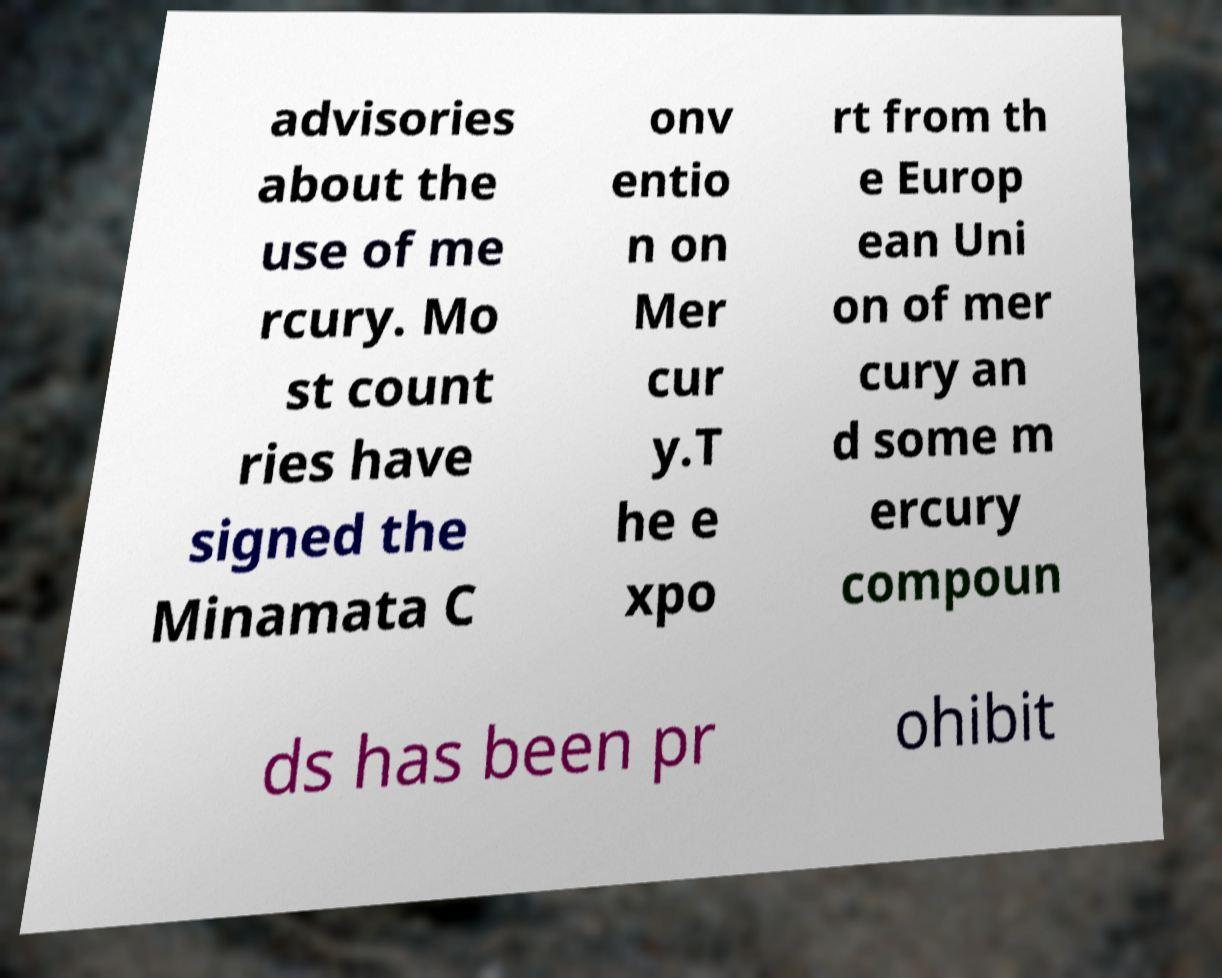Please identify and transcribe the text found in this image. advisories about the use of me rcury. Mo st count ries have signed the Minamata C onv entio n on Mer cur y.T he e xpo rt from th e Europ ean Uni on of mer cury an d some m ercury compoun ds has been pr ohibit 